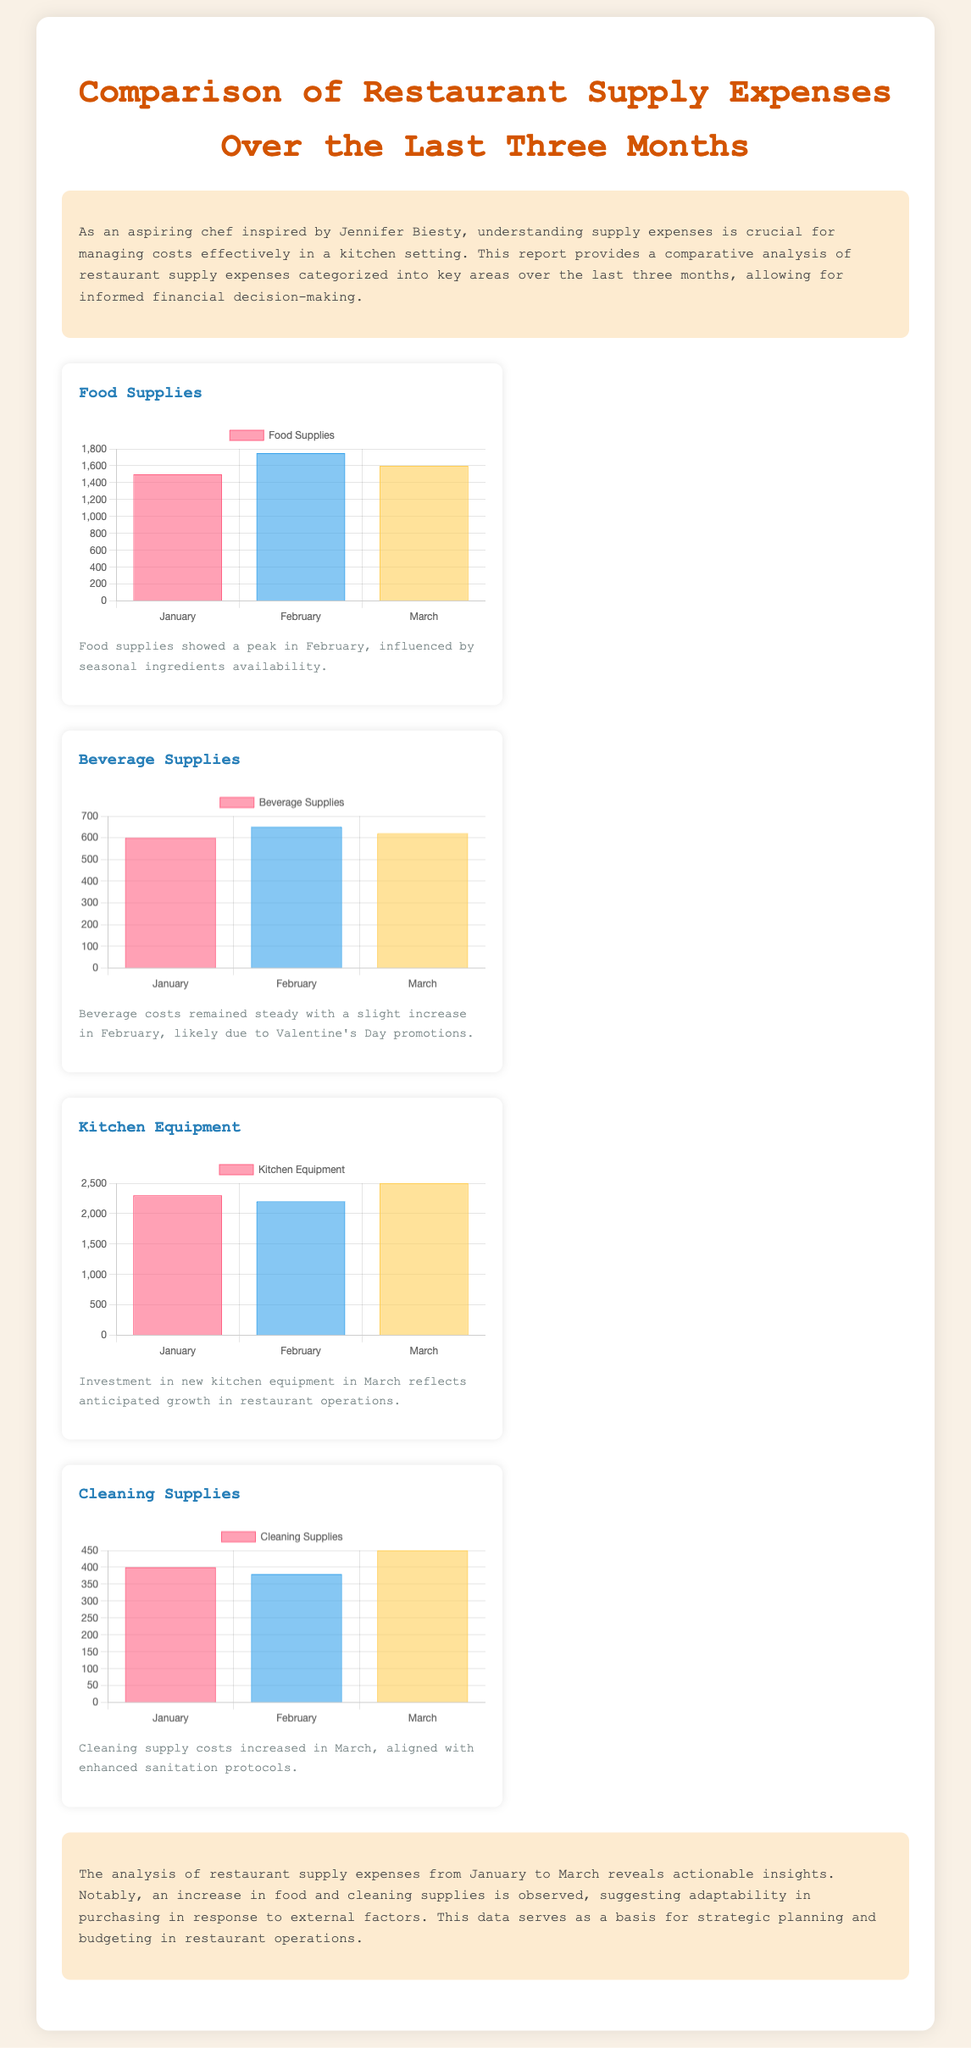What were the food supplies expenses in February? The food supplies expenses in February are highlighted in the graph showing a peak for that month.
Answer: 1750 How much was spent on beverage supplies in March? The beverage supplies for March can be found by looking at the respective bar in the chart.
Answer: 620 What is the highest expense category reported? The highest expense category can be identified by comparing the amounts in each graph and seeing which is the largest.
Answer: Kitchen Equipment Which month saw the lowest cleaning supplies expense? The lowest cleaning supplies expense is reflected in the corresponding bar for that month in the chart.
Answer: January What was the total expense for food supplies over three months? The total expense can be calculated by summing the individual monthly expenses from the chart: 1500 + 1750 + 1600.
Answer: 4850 Why did beverage costs increase slightly in February? The explanation is provided in the descriptive text accompanying the beverage supplies chart, mentioning a specific event.
Answer: Valentine's Day promotions What was the expense for kitchen equipment in January? The amount can be found directly from the kitchen equipment chart for January.
Answer: 2300 In which category did expenses increase in March? This requires looking at the trends shown in the charts to identify which category had an increase that month.
Answer: Cleaning Supplies What does the report suggest about food and cleaning supplies expenses? The report provides an overall evaluation of the expenses in the summary section, indicating a trend.
Answer: Increased expenses 